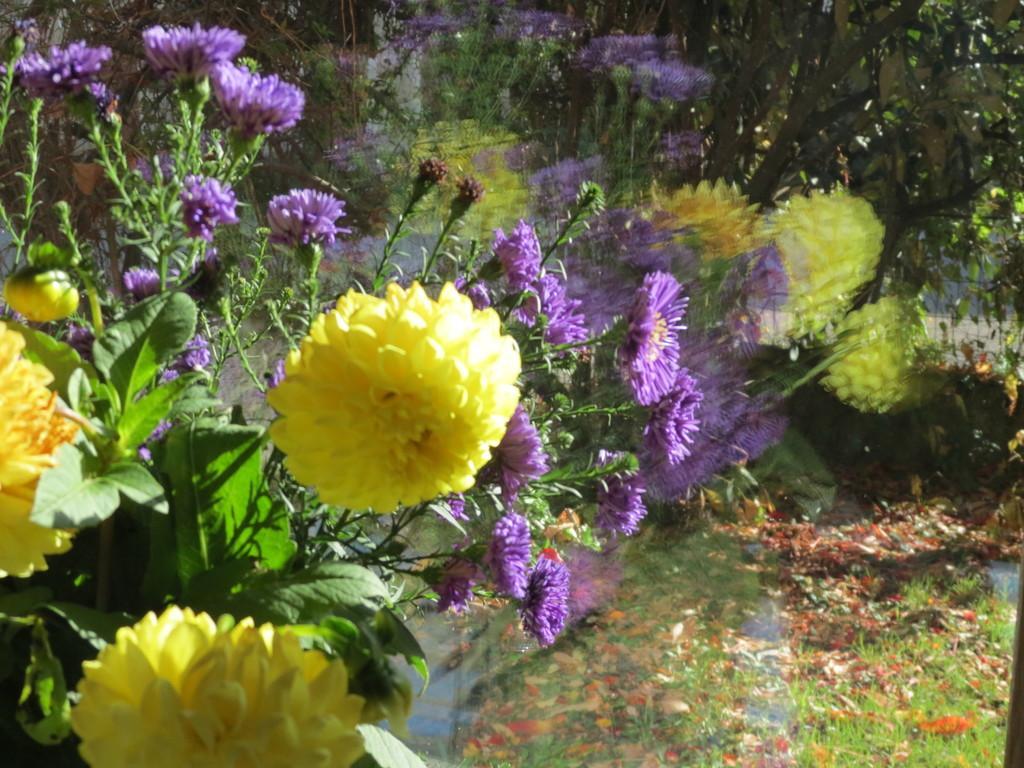Please provide a concise description of this image. In this image I can see few yellow and purple flowers and green leaves. Background is blurred and I can see green grass. 